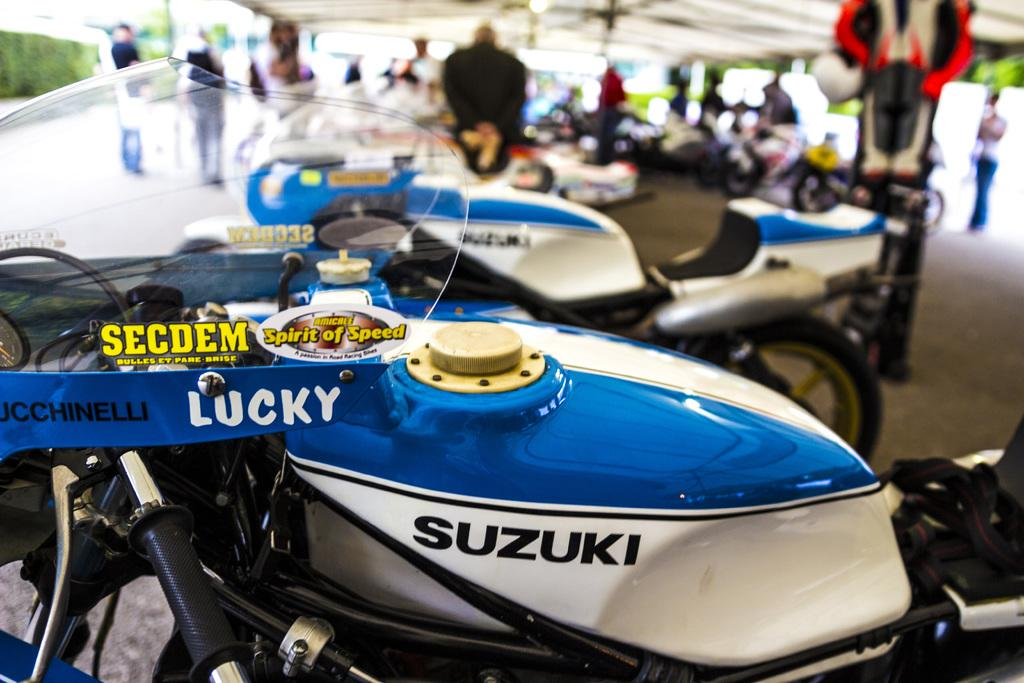What is the main subject of the image? The main subject of the image is many motorcycles. Are there any people present in the image? Yes, there are persons standing in the back. What can be seen on either side of the motorcycles? There are plants on either side of the motorcycles. What type of knowledge can be gained from the page in the image? There is no page present in the image, so no knowledge can be gained from it. 